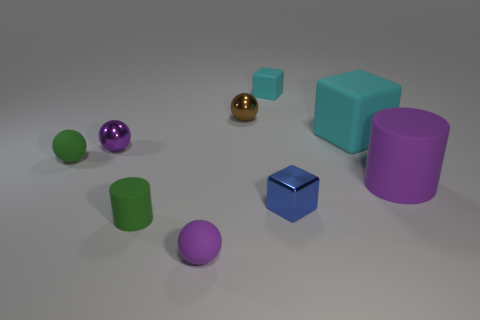Is the shape of the tiny green matte object that is in front of the tiny green ball the same as the purple matte object that is right of the small brown shiny ball? Yes, both the tiny green matte object in front of the tiny green ball and the purple matte object to the right of the small brown shiny ball are cube-shaped, sharing the same geometric properties of six square faces, twelve straight edges, and eight vertices. 